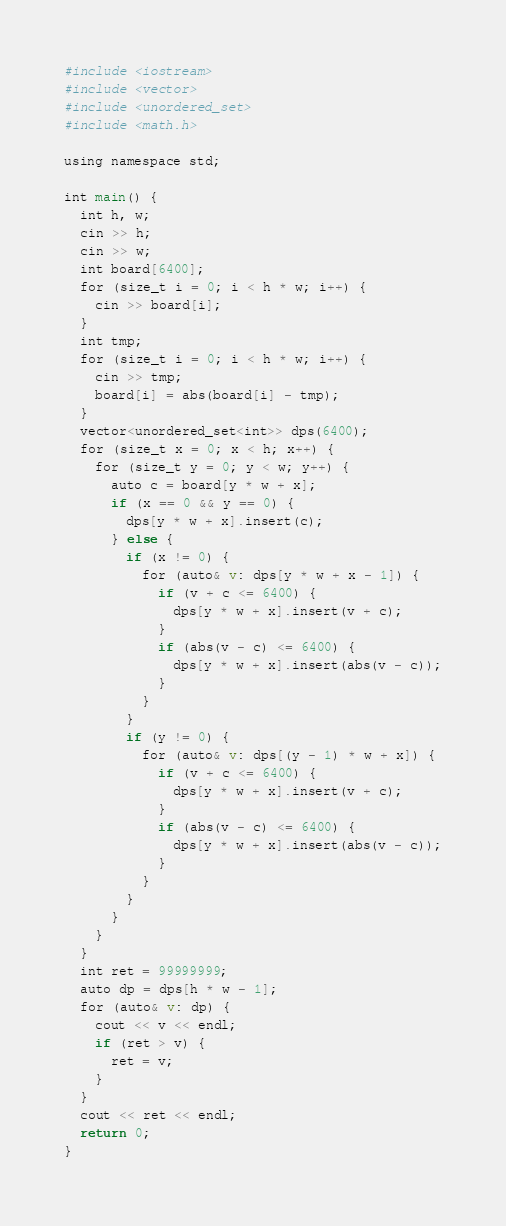Convert code to text. <code><loc_0><loc_0><loc_500><loc_500><_Crystal_>#include <iostream>
#include <vector>
#include <unordered_set>
#include <math.h>

using namespace std;

int main() {
  int h, w;
  cin >> h;
  cin >> w;
  int board[6400];
  for (size_t i = 0; i < h * w; i++) {
    cin >> board[i];
  }
  int tmp;
  for (size_t i = 0; i < h * w; i++) {
    cin >> tmp;
    board[i] = abs(board[i] - tmp);
  }
  vector<unordered_set<int>> dps(6400);
  for (size_t x = 0; x < h; x++) {
    for (size_t y = 0; y < w; y++) {
      auto c = board[y * w + x];
      if (x == 0 && y == 0) {
        dps[y * w + x].insert(c);
      } else {
        if (x != 0) {
          for (auto& v: dps[y * w + x - 1]) {
            if (v + c <= 6400) {
              dps[y * w + x].insert(v + c);
            }
            if (abs(v - c) <= 6400) {
              dps[y * w + x].insert(abs(v - c));
            }
          }
        }
        if (y != 0) {
          for (auto& v: dps[(y - 1) * w + x]) {
            if (v + c <= 6400) {
              dps[y * w + x].insert(v + c);
            }
            if (abs(v - c) <= 6400) {
              dps[y * w + x].insert(abs(v - c));
            }
          }
        }
      }
    }
  }
  int ret = 99999999;
  auto dp = dps[h * w - 1];
  for (auto& v: dp) {
    cout << v << endl;
    if (ret > v) {
      ret = v;
    }
  }
  cout << ret << endl;
  return 0;
}</code> 